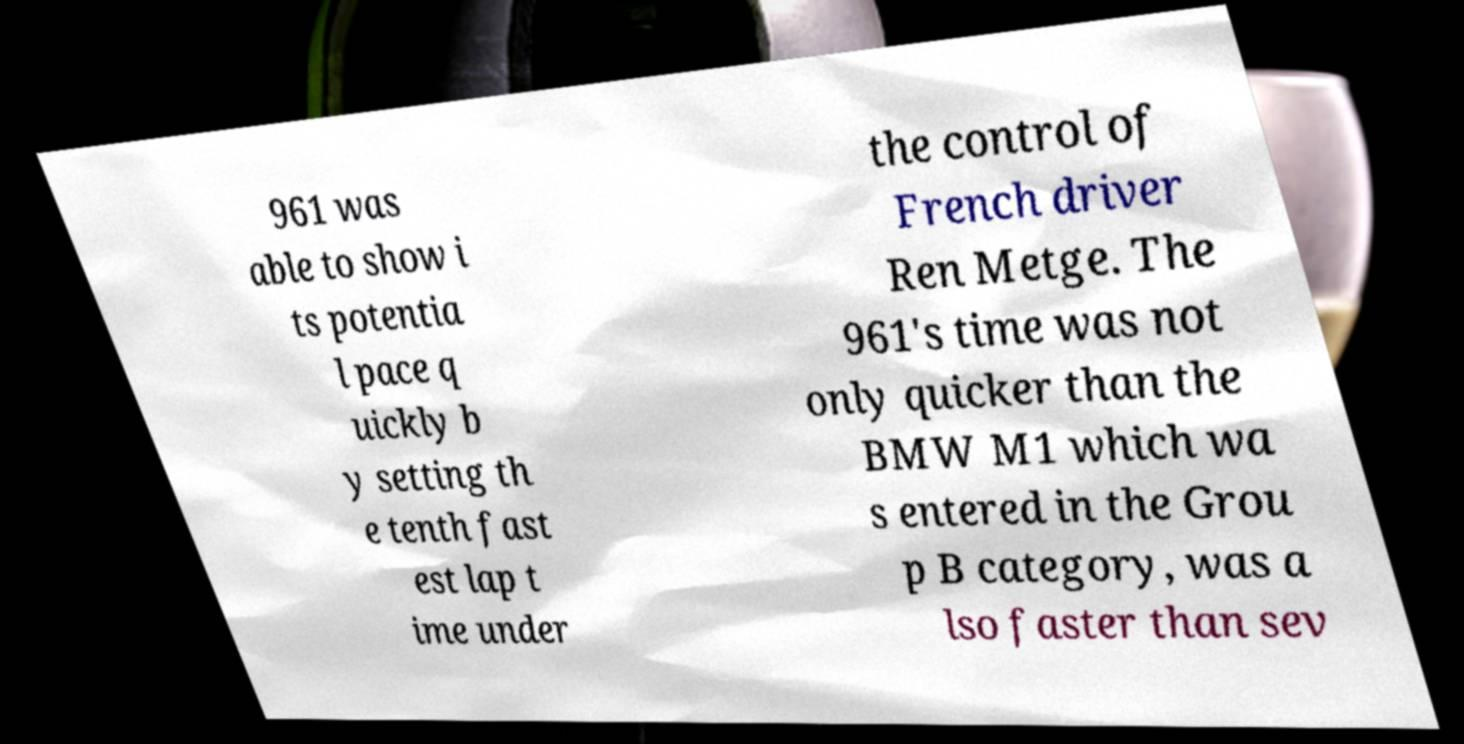Please read and relay the text visible in this image. What does it say? 961 was able to show i ts potentia l pace q uickly b y setting th e tenth fast est lap t ime under the control of French driver Ren Metge. The 961's time was not only quicker than the BMW M1 which wa s entered in the Grou p B category, was a lso faster than sev 